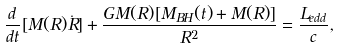<formula> <loc_0><loc_0><loc_500><loc_500>\frac { d } { d t } [ M ( R ) \dot { R } ] + \frac { G M ( R ) [ M _ { B H } ( t ) + M ( R ) ] } { R ^ { 2 } } = \frac { L _ { e d d } } { c } ,</formula> 